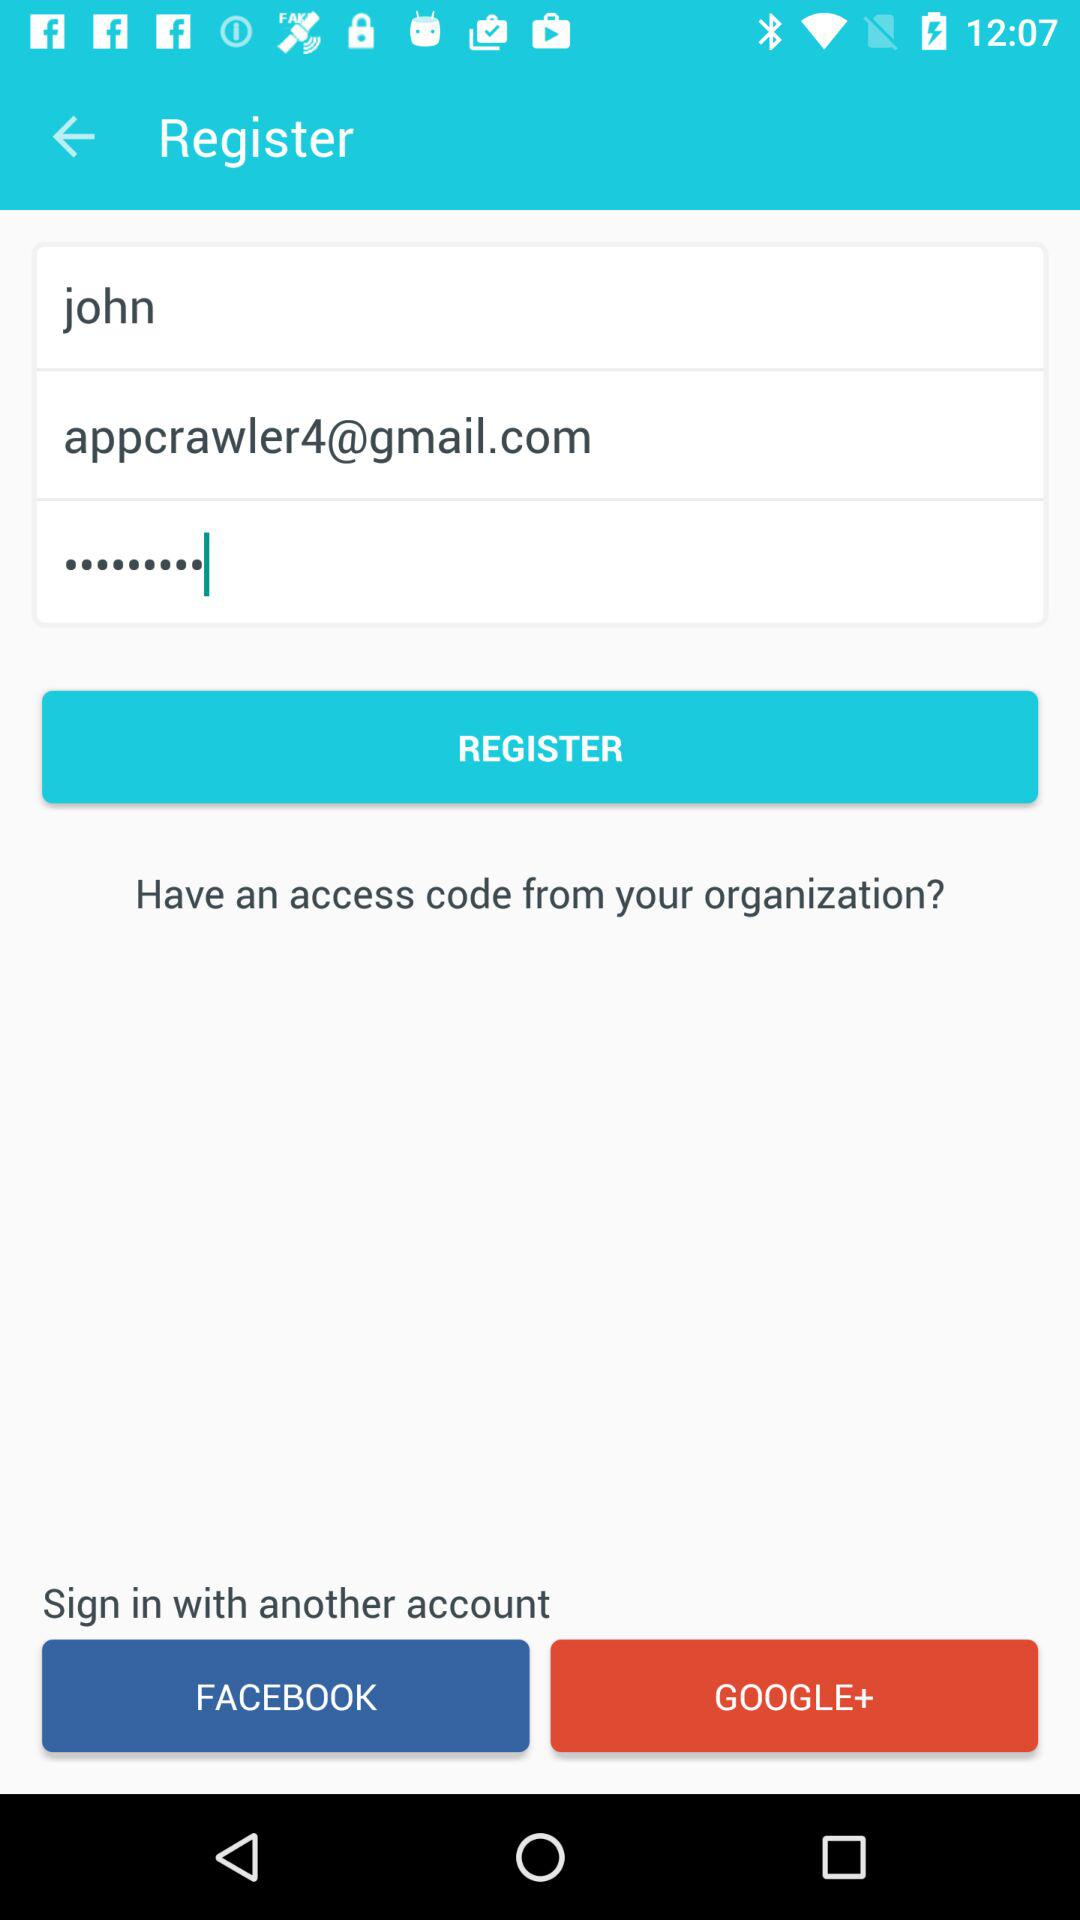What is the email address? The email address is appcrawler4@gmail.com. 